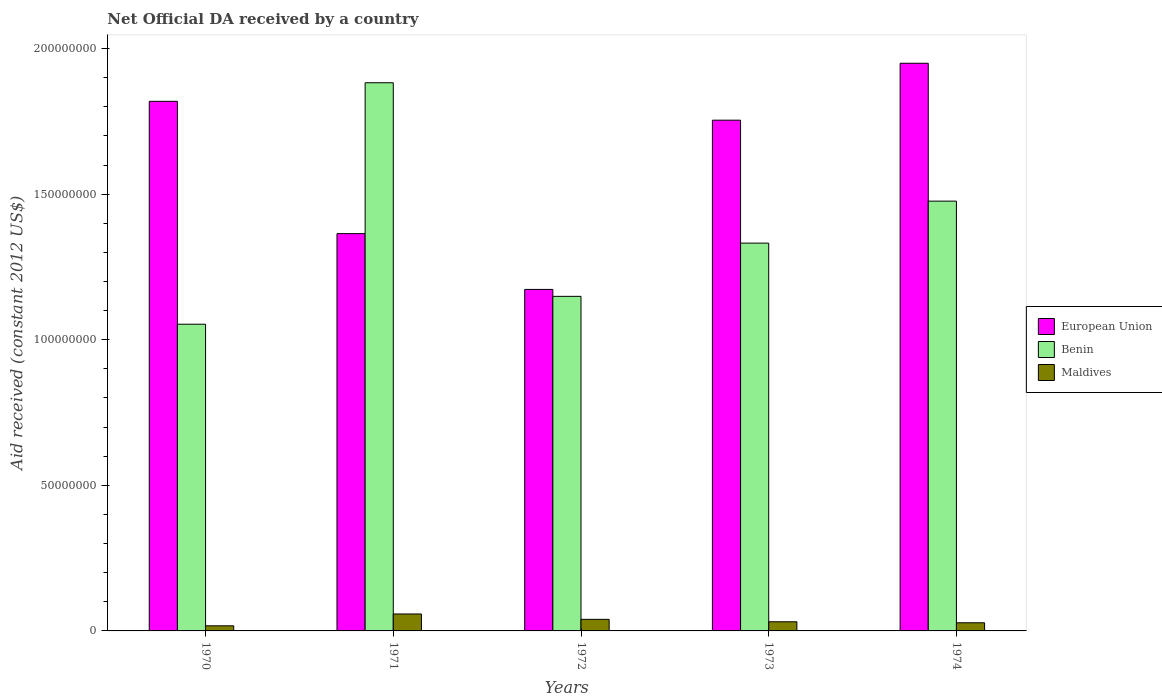How many bars are there on the 2nd tick from the left?
Offer a very short reply. 3. How many bars are there on the 4th tick from the right?
Provide a succinct answer. 3. What is the label of the 4th group of bars from the left?
Offer a very short reply. 1973. What is the net official development assistance aid received in European Union in 1972?
Ensure brevity in your answer.  1.17e+08. Across all years, what is the maximum net official development assistance aid received in Maldives?
Offer a terse response. 5.82e+06. Across all years, what is the minimum net official development assistance aid received in Benin?
Provide a succinct answer. 1.05e+08. What is the total net official development assistance aid received in Benin in the graph?
Provide a succinct answer. 6.89e+08. What is the difference between the net official development assistance aid received in Maldives in 1971 and that in 1973?
Keep it short and to the point. 2.68e+06. What is the difference between the net official development assistance aid received in European Union in 1973 and the net official development assistance aid received in Benin in 1972?
Offer a very short reply. 6.05e+07. What is the average net official development assistance aid received in Benin per year?
Provide a short and direct response. 1.38e+08. In the year 1970, what is the difference between the net official development assistance aid received in Benin and net official development assistance aid received in European Union?
Your response must be concise. -7.66e+07. In how many years, is the net official development assistance aid received in European Union greater than 170000000 US$?
Offer a terse response. 3. What is the ratio of the net official development assistance aid received in Benin in 1970 to that in 1972?
Your response must be concise. 0.92. What is the difference between the highest and the second highest net official development assistance aid received in Maldives?
Your response must be concise. 1.84e+06. What is the difference between the highest and the lowest net official development assistance aid received in Maldives?
Make the answer very short. 4.07e+06. What does the 2nd bar from the left in 1973 represents?
Provide a short and direct response. Benin. What does the 1st bar from the right in 1973 represents?
Keep it short and to the point. Maldives. How many years are there in the graph?
Give a very brief answer. 5. What is the difference between two consecutive major ticks on the Y-axis?
Offer a terse response. 5.00e+07. Does the graph contain any zero values?
Provide a succinct answer. No. Where does the legend appear in the graph?
Your answer should be compact. Center right. How many legend labels are there?
Your answer should be compact. 3. What is the title of the graph?
Provide a succinct answer. Net Official DA received by a country. What is the label or title of the Y-axis?
Make the answer very short. Aid received (constant 2012 US$). What is the Aid received (constant 2012 US$) of European Union in 1970?
Your answer should be very brief. 1.82e+08. What is the Aid received (constant 2012 US$) of Benin in 1970?
Provide a short and direct response. 1.05e+08. What is the Aid received (constant 2012 US$) of Maldives in 1970?
Make the answer very short. 1.75e+06. What is the Aid received (constant 2012 US$) in European Union in 1971?
Provide a short and direct response. 1.36e+08. What is the Aid received (constant 2012 US$) of Benin in 1971?
Give a very brief answer. 1.88e+08. What is the Aid received (constant 2012 US$) of Maldives in 1971?
Your answer should be compact. 5.82e+06. What is the Aid received (constant 2012 US$) of European Union in 1972?
Offer a very short reply. 1.17e+08. What is the Aid received (constant 2012 US$) in Benin in 1972?
Your answer should be very brief. 1.15e+08. What is the Aid received (constant 2012 US$) of Maldives in 1972?
Give a very brief answer. 3.98e+06. What is the Aid received (constant 2012 US$) in European Union in 1973?
Offer a very short reply. 1.75e+08. What is the Aid received (constant 2012 US$) in Benin in 1973?
Your response must be concise. 1.33e+08. What is the Aid received (constant 2012 US$) in Maldives in 1973?
Keep it short and to the point. 3.14e+06. What is the Aid received (constant 2012 US$) of European Union in 1974?
Your answer should be very brief. 1.95e+08. What is the Aid received (constant 2012 US$) of Benin in 1974?
Make the answer very short. 1.48e+08. What is the Aid received (constant 2012 US$) in Maldives in 1974?
Ensure brevity in your answer.  2.80e+06. Across all years, what is the maximum Aid received (constant 2012 US$) in European Union?
Your answer should be compact. 1.95e+08. Across all years, what is the maximum Aid received (constant 2012 US$) of Benin?
Provide a succinct answer. 1.88e+08. Across all years, what is the maximum Aid received (constant 2012 US$) in Maldives?
Your response must be concise. 5.82e+06. Across all years, what is the minimum Aid received (constant 2012 US$) of European Union?
Give a very brief answer. 1.17e+08. Across all years, what is the minimum Aid received (constant 2012 US$) of Benin?
Your answer should be very brief. 1.05e+08. Across all years, what is the minimum Aid received (constant 2012 US$) of Maldives?
Give a very brief answer. 1.75e+06. What is the total Aid received (constant 2012 US$) in European Union in the graph?
Offer a terse response. 8.06e+08. What is the total Aid received (constant 2012 US$) of Benin in the graph?
Keep it short and to the point. 6.89e+08. What is the total Aid received (constant 2012 US$) of Maldives in the graph?
Offer a very short reply. 1.75e+07. What is the difference between the Aid received (constant 2012 US$) of European Union in 1970 and that in 1971?
Provide a short and direct response. 4.54e+07. What is the difference between the Aid received (constant 2012 US$) of Benin in 1970 and that in 1971?
Make the answer very short. -8.29e+07. What is the difference between the Aid received (constant 2012 US$) in Maldives in 1970 and that in 1971?
Offer a terse response. -4.07e+06. What is the difference between the Aid received (constant 2012 US$) in European Union in 1970 and that in 1972?
Your answer should be very brief. 6.46e+07. What is the difference between the Aid received (constant 2012 US$) in Benin in 1970 and that in 1972?
Your answer should be compact. -9.57e+06. What is the difference between the Aid received (constant 2012 US$) of Maldives in 1970 and that in 1972?
Your answer should be very brief. -2.23e+06. What is the difference between the Aid received (constant 2012 US$) of European Union in 1970 and that in 1973?
Offer a terse response. 6.48e+06. What is the difference between the Aid received (constant 2012 US$) in Benin in 1970 and that in 1973?
Ensure brevity in your answer.  -2.78e+07. What is the difference between the Aid received (constant 2012 US$) in Maldives in 1970 and that in 1973?
Offer a very short reply. -1.39e+06. What is the difference between the Aid received (constant 2012 US$) of European Union in 1970 and that in 1974?
Your answer should be compact. -1.31e+07. What is the difference between the Aid received (constant 2012 US$) of Benin in 1970 and that in 1974?
Keep it short and to the point. -4.23e+07. What is the difference between the Aid received (constant 2012 US$) of Maldives in 1970 and that in 1974?
Give a very brief answer. -1.05e+06. What is the difference between the Aid received (constant 2012 US$) of European Union in 1971 and that in 1972?
Your answer should be compact. 1.92e+07. What is the difference between the Aid received (constant 2012 US$) of Benin in 1971 and that in 1972?
Offer a very short reply. 7.34e+07. What is the difference between the Aid received (constant 2012 US$) in Maldives in 1971 and that in 1972?
Provide a short and direct response. 1.84e+06. What is the difference between the Aid received (constant 2012 US$) in European Union in 1971 and that in 1973?
Offer a terse response. -3.90e+07. What is the difference between the Aid received (constant 2012 US$) in Benin in 1971 and that in 1973?
Make the answer very short. 5.51e+07. What is the difference between the Aid received (constant 2012 US$) of Maldives in 1971 and that in 1973?
Ensure brevity in your answer.  2.68e+06. What is the difference between the Aid received (constant 2012 US$) of European Union in 1971 and that in 1974?
Give a very brief answer. -5.85e+07. What is the difference between the Aid received (constant 2012 US$) of Benin in 1971 and that in 1974?
Give a very brief answer. 4.07e+07. What is the difference between the Aid received (constant 2012 US$) of Maldives in 1971 and that in 1974?
Your answer should be very brief. 3.02e+06. What is the difference between the Aid received (constant 2012 US$) of European Union in 1972 and that in 1973?
Provide a succinct answer. -5.81e+07. What is the difference between the Aid received (constant 2012 US$) in Benin in 1972 and that in 1973?
Make the answer very short. -1.83e+07. What is the difference between the Aid received (constant 2012 US$) in Maldives in 1972 and that in 1973?
Offer a very short reply. 8.40e+05. What is the difference between the Aid received (constant 2012 US$) in European Union in 1972 and that in 1974?
Offer a very short reply. -7.77e+07. What is the difference between the Aid received (constant 2012 US$) in Benin in 1972 and that in 1974?
Keep it short and to the point. -3.27e+07. What is the difference between the Aid received (constant 2012 US$) of Maldives in 1972 and that in 1974?
Offer a terse response. 1.18e+06. What is the difference between the Aid received (constant 2012 US$) in European Union in 1973 and that in 1974?
Provide a short and direct response. -1.96e+07. What is the difference between the Aid received (constant 2012 US$) of Benin in 1973 and that in 1974?
Offer a very short reply. -1.44e+07. What is the difference between the Aid received (constant 2012 US$) of European Union in 1970 and the Aid received (constant 2012 US$) of Benin in 1971?
Provide a succinct answer. -6.38e+06. What is the difference between the Aid received (constant 2012 US$) in European Union in 1970 and the Aid received (constant 2012 US$) in Maldives in 1971?
Offer a terse response. 1.76e+08. What is the difference between the Aid received (constant 2012 US$) of Benin in 1970 and the Aid received (constant 2012 US$) of Maldives in 1971?
Provide a succinct answer. 9.95e+07. What is the difference between the Aid received (constant 2012 US$) of European Union in 1970 and the Aid received (constant 2012 US$) of Benin in 1972?
Your answer should be compact. 6.70e+07. What is the difference between the Aid received (constant 2012 US$) in European Union in 1970 and the Aid received (constant 2012 US$) in Maldives in 1972?
Offer a terse response. 1.78e+08. What is the difference between the Aid received (constant 2012 US$) of Benin in 1970 and the Aid received (constant 2012 US$) of Maldives in 1972?
Offer a very short reply. 1.01e+08. What is the difference between the Aid received (constant 2012 US$) of European Union in 1970 and the Aid received (constant 2012 US$) of Benin in 1973?
Offer a terse response. 4.87e+07. What is the difference between the Aid received (constant 2012 US$) in European Union in 1970 and the Aid received (constant 2012 US$) in Maldives in 1973?
Provide a short and direct response. 1.79e+08. What is the difference between the Aid received (constant 2012 US$) in Benin in 1970 and the Aid received (constant 2012 US$) in Maldives in 1973?
Your answer should be very brief. 1.02e+08. What is the difference between the Aid received (constant 2012 US$) of European Union in 1970 and the Aid received (constant 2012 US$) of Benin in 1974?
Give a very brief answer. 3.43e+07. What is the difference between the Aid received (constant 2012 US$) in European Union in 1970 and the Aid received (constant 2012 US$) in Maldives in 1974?
Offer a terse response. 1.79e+08. What is the difference between the Aid received (constant 2012 US$) in Benin in 1970 and the Aid received (constant 2012 US$) in Maldives in 1974?
Your answer should be compact. 1.03e+08. What is the difference between the Aid received (constant 2012 US$) of European Union in 1971 and the Aid received (constant 2012 US$) of Benin in 1972?
Give a very brief answer. 2.15e+07. What is the difference between the Aid received (constant 2012 US$) in European Union in 1971 and the Aid received (constant 2012 US$) in Maldives in 1972?
Make the answer very short. 1.32e+08. What is the difference between the Aid received (constant 2012 US$) in Benin in 1971 and the Aid received (constant 2012 US$) in Maldives in 1972?
Your answer should be compact. 1.84e+08. What is the difference between the Aid received (constant 2012 US$) of European Union in 1971 and the Aid received (constant 2012 US$) of Benin in 1973?
Ensure brevity in your answer.  3.26e+06. What is the difference between the Aid received (constant 2012 US$) of European Union in 1971 and the Aid received (constant 2012 US$) of Maldives in 1973?
Your response must be concise. 1.33e+08. What is the difference between the Aid received (constant 2012 US$) of Benin in 1971 and the Aid received (constant 2012 US$) of Maldives in 1973?
Ensure brevity in your answer.  1.85e+08. What is the difference between the Aid received (constant 2012 US$) of European Union in 1971 and the Aid received (constant 2012 US$) of Benin in 1974?
Your response must be concise. -1.12e+07. What is the difference between the Aid received (constant 2012 US$) of European Union in 1971 and the Aid received (constant 2012 US$) of Maldives in 1974?
Keep it short and to the point. 1.34e+08. What is the difference between the Aid received (constant 2012 US$) of Benin in 1971 and the Aid received (constant 2012 US$) of Maldives in 1974?
Your answer should be compact. 1.85e+08. What is the difference between the Aid received (constant 2012 US$) of European Union in 1972 and the Aid received (constant 2012 US$) of Benin in 1973?
Your answer should be compact. -1.59e+07. What is the difference between the Aid received (constant 2012 US$) in European Union in 1972 and the Aid received (constant 2012 US$) in Maldives in 1973?
Provide a short and direct response. 1.14e+08. What is the difference between the Aid received (constant 2012 US$) in Benin in 1972 and the Aid received (constant 2012 US$) in Maldives in 1973?
Make the answer very short. 1.12e+08. What is the difference between the Aid received (constant 2012 US$) in European Union in 1972 and the Aid received (constant 2012 US$) in Benin in 1974?
Keep it short and to the point. -3.03e+07. What is the difference between the Aid received (constant 2012 US$) of European Union in 1972 and the Aid received (constant 2012 US$) of Maldives in 1974?
Give a very brief answer. 1.14e+08. What is the difference between the Aid received (constant 2012 US$) of Benin in 1972 and the Aid received (constant 2012 US$) of Maldives in 1974?
Keep it short and to the point. 1.12e+08. What is the difference between the Aid received (constant 2012 US$) in European Union in 1973 and the Aid received (constant 2012 US$) in Benin in 1974?
Provide a short and direct response. 2.78e+07. What is the difference between the Aid received (constant 2012 US$) of European Union in 1973 and the Aid received (constant 2012 US$) of Maldives in 1974?
Your answer should be very brief. 1.73e+08. What is the difference between the Aid received (constant 2012 US$) of Benin in 1973 and the Aid received (constant 2012 US$) of Maldives in 1974?
Make the answer very short. 1.30e+08. What is the average Aid received (constant 2012 US$) of European Union per year?
Offer a very short reply. 1.61e+08. What is the average Aid received (constant 2012 US$) in Benin per year?
Provide a succinct answer. 1.38e+08. What is the average Aid received (constant 2012 US$) of Maldives per year?
Provide a short and direct response. 3.50e+06. In the year 1970, what is the difference between the Aid received (constant 2012 US$) in European Union and Aid received (constant 2012 US$) in Benin?
Make the answer very short. 7.66e+07. In the year 1970, what is the difference between the Aid received (constant 2012 US$) of European Union and Aid received (constant 2012 US$) of Maldives?
Your answer should be very brief. 1.80e+08. In the year 1970, what is the difference between the Aid received (constant 2012 US$) of Benin and Aid received (constant 2012 US$) of Maldives?
Your response must be concise. 1.04e+08. In the year 1971, what is the difference between the Aid received (constant 2012 US$) in European Union and Aid received (constant 2012 US$) in Benin?
Provide a succinct answer. -5.18e+07. In the year 1971, what is the difference between the Aid received (constant 2012 US$) in European Union and Aid received (constant 2012 US$) in Maldives?
Your response must be concise. 1.31e+08. In the year 1971, what is the difference between the Aid received (constant 2012 US$) of Benin and Aid received (constant 2012 US$) of Maldives?
Ensure brevity in your answer.  1.82e+08. In the year 1972, what is the difference between the Aid received (constant 2012 US$) of European Union and Aid received (constant 2012 US$) of Benin?
Keep it short and to the point. 2.38e+06. In the year 1972, what is the difference between the Aid received (constant 2012 US$) of European Union and Aid received (constant 2012 US$) of Maldives?
Your answer should be compact. 1.13e+08. In the year 1972, what is the difference between the Aid received (constant 2012 US$) in Benin and Aid received (constant 2012 US$) in Maldives?
Your answer should be compact. 1.11e+08. In the year 1973, what is the difference between the Aid received (constant 2012 US$) in European Union and Aid received (constant 2012 US$) in Benin?
Offer a terse response. 4.22e+07. In the year 1973, what is the difference between the Aid received (constant 2012 US$) in European Union and Aid received (constant 2012 US$) in Maldives?
Make the answer very short. 1.72e+08. In the year 1973, what is the difference between the Aid received (constant 2012 US$) in Benin and Aid received (constant 2012 US$) in Maldives?
Provide a short and direct response. 1.30e+08. In the year 1974, what is the difference between the Aid received (constant 2012 US$) in European Union and Aid received (constant 2012 US$) in Benin?
Offer a very short reply. 4.74e+07. In the year 1974, what is the difference between the Aid received (constant 2012 US$) of European Union and Aid received (constant 2012 US$) of Maldives?
Provide a succinct answer. 1.92e+08. In the year 1974, what is the difference between the Aid received (constant 2012 US$) of Benin and Aid received (constant 2012 US$) of Maldives?
Your response must be concise. 1.45e+08. What is the ratio of the Aid received (constant 2012 US$) of European Union in 1970 to that in 1971?
Offer a very short reply. 1.33. What is the ratio of the Aid received (constant 2012 US$) in Benin in 1970 to that in 1971?
Your response must be concise. 0.56. What is the ratio of the Aid received (constant 2012 US$) in Maldives in 1970 to that in 1971?
Provide a succinct answer. 0.3. What is the ratio of the Aid received (constant 2012 US$) of European Union in 1970 to that in 1972?
Offer a terse response. 1.55. What is the ratio of the Aid received (constant 2012 US$) in Benin in 1970 to that in 1972?
Give a very brief answer. 0.92. What is the ratio of the Aid received (constant 2012 US$) in Maldives in 1970 to that in 1972?
Provide a succinct answer. 0.44. What is the ratio of the Aid received (constant 2012 US$) in European Union in 1970 to that in 1973?
Offer a terse response. 1.04. What is the ratio of the Aid received (constant 2012 US$) in Benin in 1970 to that in 1973?
Offer a very short reply. 0.79. What is the ratio of the Aid received (constant 2012 US$) in Maldives in 1970 to that in 1973?
Your answer should be very brief. 0.56. What is the ratio of the Aid received (constant 2012 US$) in European Union in 1970 to that in 1974?
Your answer should be very brief. 0.93. What is the ratio of the Aid received (constant 2012 US$) of Benin in 1970 to that in 1974?
Offer a very short reply. 0.71. What is the ratio of the Aid received (constant 2012 US$) of Maldives in 1970 to that in 1974?
Offer a very short reply. 0.62. What is the ratio of the Aid received (constant 2012 US$) of European Union in 1971 to that in 1972?
Provide a succinct answer. 1.16. What is the ratio of the Aid received (constant 2012 US$) of Benin in 1971 to that in 1972?
Your response must be concise. 1.64. What is the ratio of the Aid received (constant 2012 US$) of Maldives in 1971 to that in 1972?
Your response must be concise. 1.46. What is the ratio of the Aid received (constant 2012 US$) of European Union in 1971 to that in 1973?
Offer a terse response. 0.78. What is the ratio of the Aid received (constant 2012 US$) of Benin in 1971 to that in 1973?
Offer a very short reply. 1.41. What is the ratio of the Aid received (constant 2012 US$) of Maldives in 1971 to that in 1973?
Ensure brevity in your answer.  1.85. What is the ratio of the Aid received (constant 2012 US$) in European Union in 1971 to that in 1974?
Keep it short and to the point. 0.7. What is the ratio of the Aid received (constant 2012 US$) in Benin in 1971 to that in 1974?
Offer a terse response. 1.28. What is the ratio of the Aid received (constant 2012 US$) in Maldives in 1971 to that in 1974?
Offer a terse response. 2.08. What is the ratio of the Aid received (constant 2012 US$) in European Union in 1972 to that in 1973?
Keep it short and to the point. 0.67. What is the ratio of the Aid received (constant 2012 US$) of Benin in 1972 to that in 1973?
Your answer should be very brief. 0.86. What is the ratio of the Aid received (constant 2012 US$) in Maldives in 1972 to that in 1973?
Your answer should be compact. 1.27. What is the ratio of the Aid received (constant 2012 US$) of European Union in 1972 to that in 1974?
Ensure brevity in your answer.  0.6. What is the ratio of the Aid received (constant 2012 US$) in Benin in 1972 to that in 1974?
Ensure brevity in your answer.  0.78. What is the ratio of the Aid received (constant 2012 US$) in Maldives in 1972 to that in 1974?
Offer a very short reply. 1.42. What is the ratio of the Aid received (constant 2012 US$) in European Union in 1973 to that in 1974?
Provide a short and direct response. 0.9. What is the ratio of the Aid received (constant 2012 US$) in Benin in 1973 to that in 1974?
Your answer should be compact. 0.9. What is the ratio of the Aid received (constant 2012 US$) in Maldives in 1973 to that in 1974?
Make the answer very short. 1.12. What is the difference between the highest and the second highest Aid received (constant 2012 US$) in European Union?
Give a very brief answer. 1.31e+07. What is the difference between the highest and the second highest Aid received (constant 2012 US$) in Benin?
Provide a succinct answer. 4.07e+07. What is the difference between the highest and the second highest Aid received (constant 2012 US$) in Maldives?
Give a very brief answer. 1.84e+06. What is the difference between the highest and the lowest Aid received (constant 2012 US$) in European Union?
Offer a very short reply. 7.77e+07. What is the difference between the highest and the lowest Aid received (constant 2012 US$) in Benin?
Offer a very short reply. 8.29e+07. What is the difference between the highest and the lowest Aid received (constant 2012 US$) of Maldives?
Ensure brevity in your answer.  4.07e+06. 